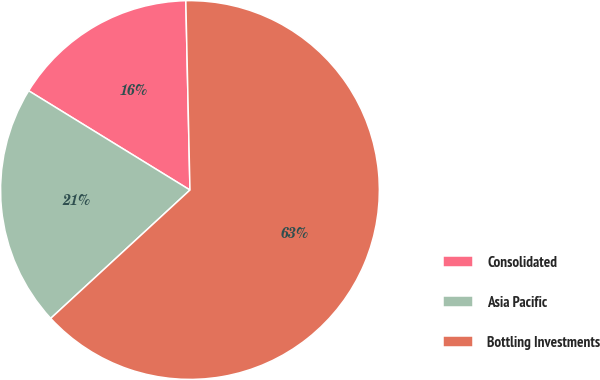Convert chart. <chart><loc_0><loc_0><loc_500><loc_500><pie_chart><fcel>Consolidated<fcel>Asia Pacific<fcel>Bottling Investments<nl><fcel>15.87%<fcel>20.63%<fcel>63.49%<nl></chart> 